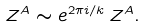<formula> <loc_0><loc_0><loc_500><loc_500>Z ^ { A } \sim e ^ { 2 \pi i / k } \, Z ^ { A } .</formula> 